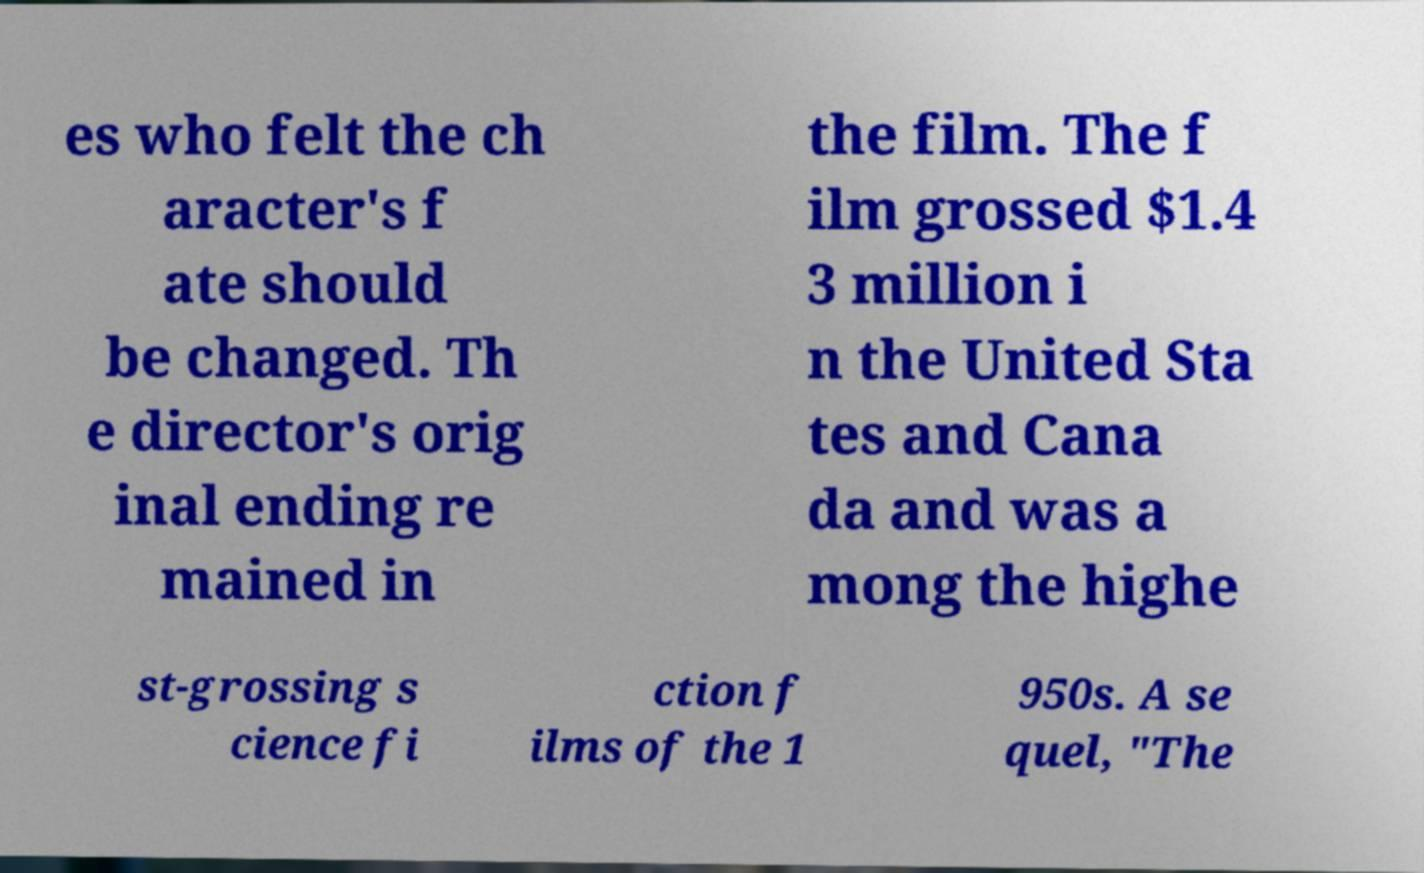Please read and relay the text visible in this image. What does it say? es who felt the ch aracter's f ate should be changed. Th e director's orig inal ending re mained in the film. The f ilm grossed $1.4 3 million i n the United Sta tes and Cana da and was a mong the highe st-grossing s cience fi ction f ilms of the 1 950s. A se quel, "The 